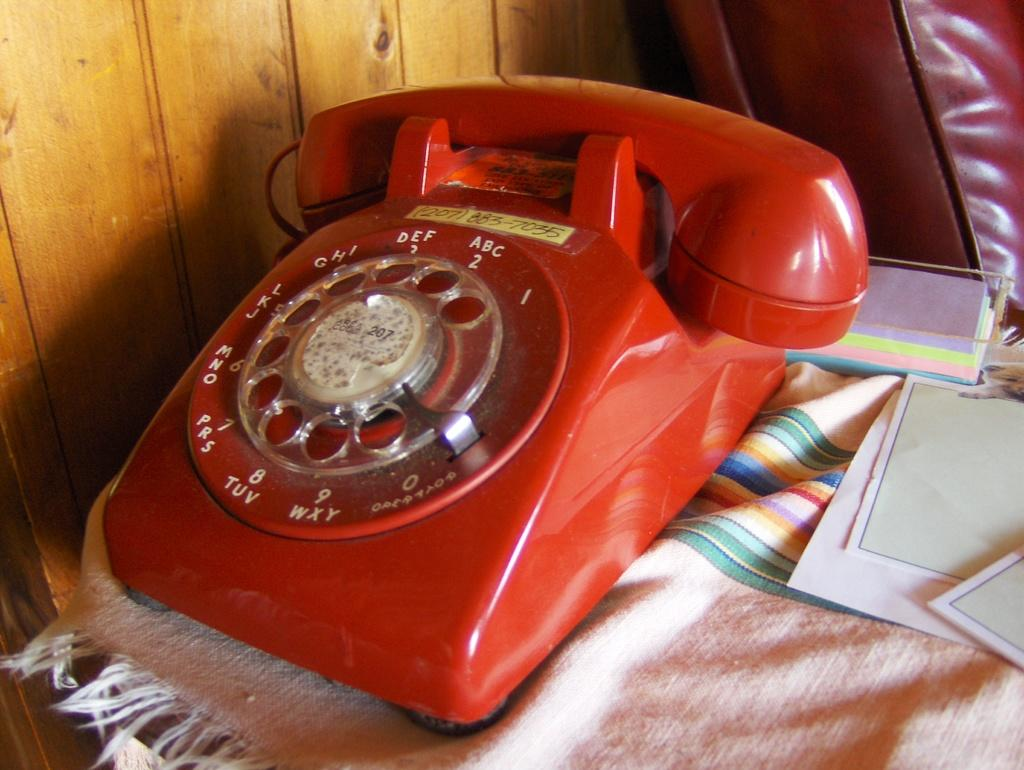What piece of furniture is present in the image? There is a table in the image. What object can be seen on the table? There is a phone on the table. What else is on the table besides the phone? There are papers on the table. What type of honey is being used to stick the papers together in the image? There is no honey or any indication of sticking papers together in the image. 